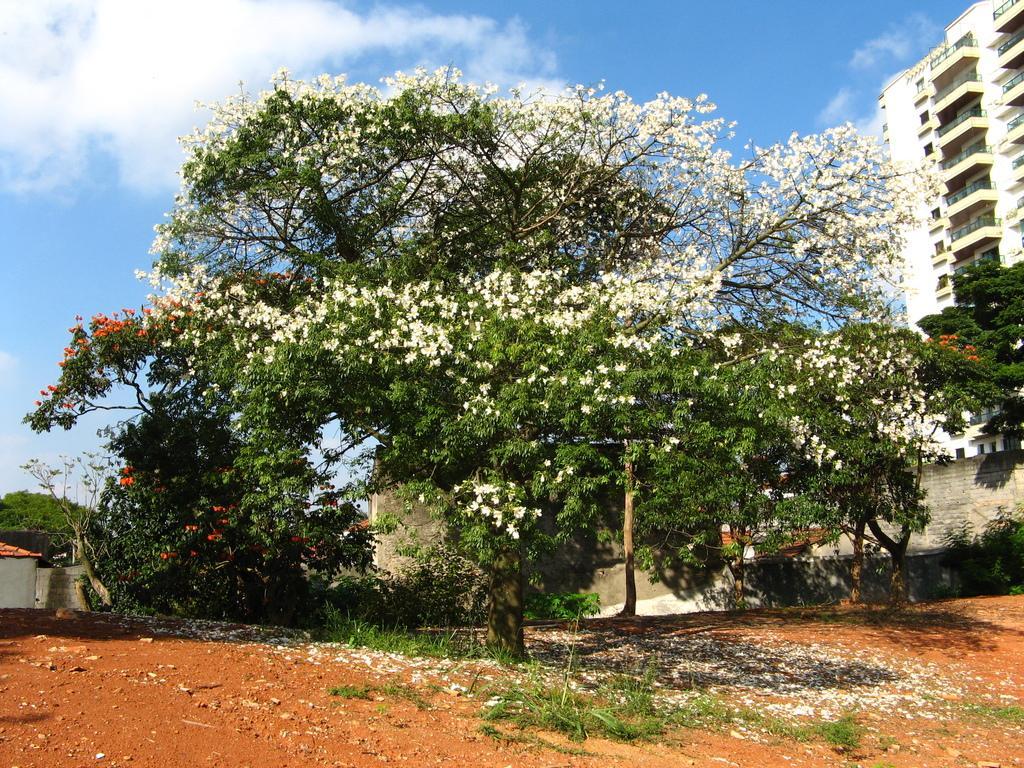How would you summarize this image in a sentence or two? In this image we can see sky with clouds, buildings, shed, trees and shredded flowers on the ground. 